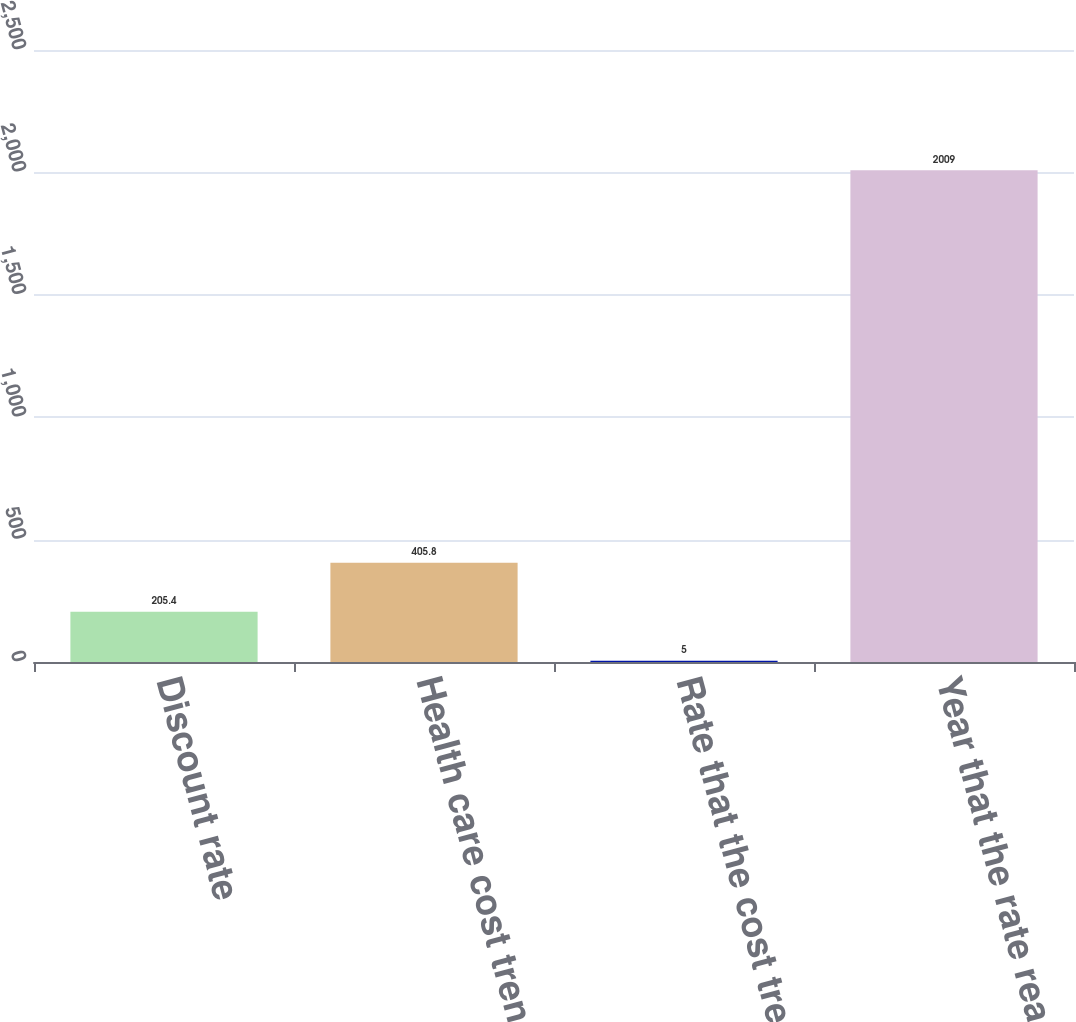<chart> <loc_0><loc_0><loc_500><loc_500><bar_chart><fcel>Discount rate<fcel>Health care cost trend rate<fcel>Rate that the cost trend rate<fcel>Year that the rate reaches the<nl><fcel>205.4<fcel>405.8<fcel>5<fcel>2009<nl></chart> 